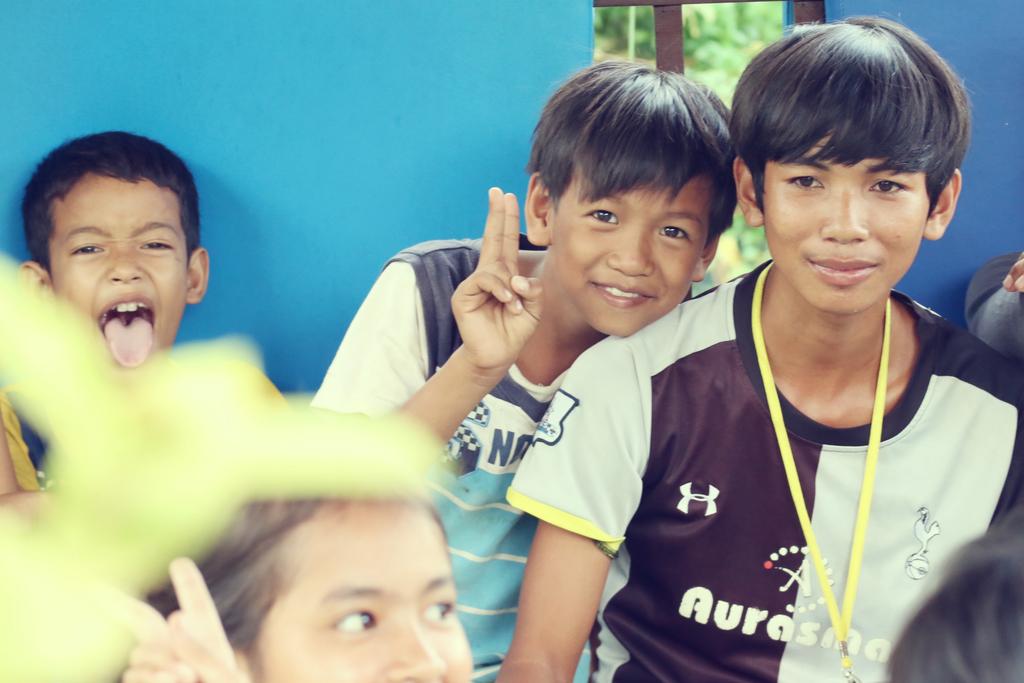Is aurasino the word on the boy's shirt?
Provide a succinct answer. Yes. What team is the kid with black shirt wearing?
Offer a terse response. Aurasma. 